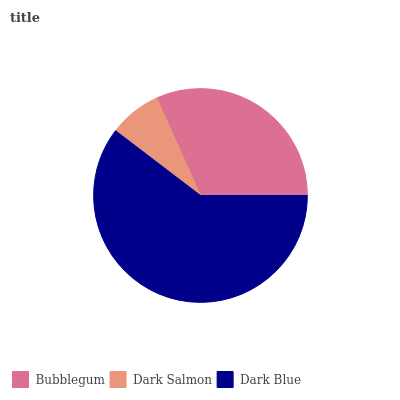Is Dark Salmon the minimum?
Answer yes or no. Yes. Is Dark Blue the maximum?
Answer yes or no. Yes. Is Dark Blue the minimum?
Answer yes or no. No. Is Dark Salmon the maximum?
Answer yes or no. No. Is Dark Blue greater than Dark Salmon?
Answer yes or no. Yes. Is Dark Salmon less than Dark Blue?
Answer yes or no. Yes. Is Dark Salmon greater than Dark Blue?
Answer yes or no. No. Is Dark Blue less than Dark Salmon?
Answer yes or no. No. Is Bubblegum the high median?
Answer yes or no. Yes. Is Bubblegum the low median?
Answer yes or no. Yes. Is Dark Salmon the high median?
Answer yes or no. No. Is Dark Blue the low median?
Answer yes or no. No. 